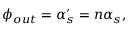<formula> <loc_0><loc_0><loc_500><loc_500>\phi _ { o u t } = \alpha _ { s } ^ { \prime } = n \alpha _ { s } ,</formula> 